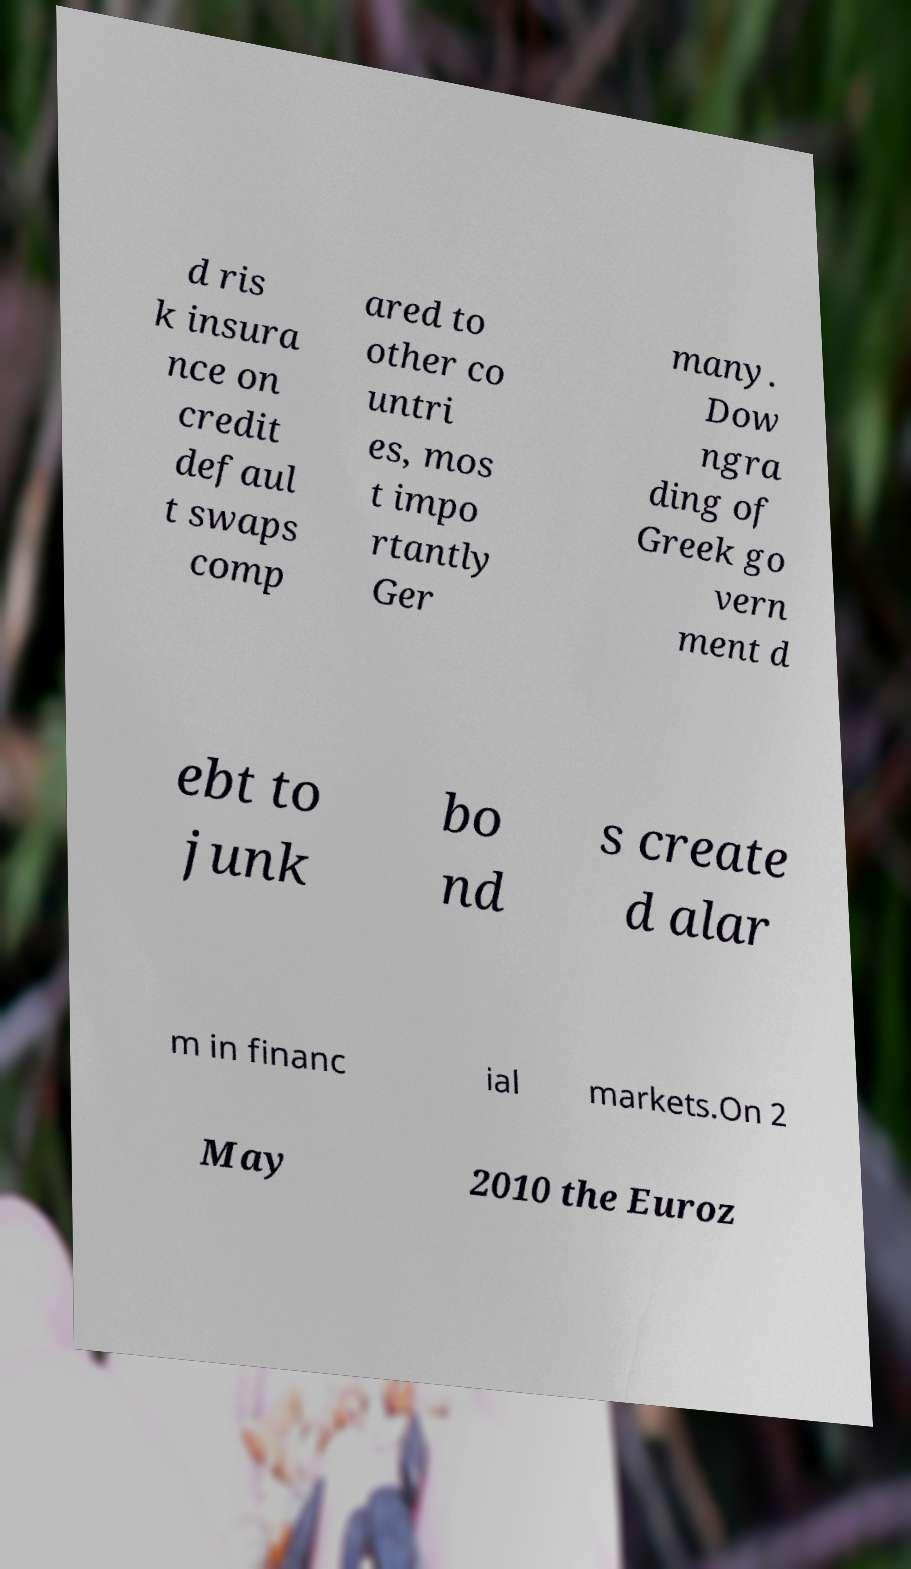What messages or text are displayed in this image? I need them in a readable, typed format. d ris k insura nce on credit defaul t swaps comp ared to other co untri es, mos t impo rtantly Ger many. Dow ngra ding of Greek go vern ment d ebt to junk bo nd s create d alar m in financ ial markets.On 2 May 2010 the Euroz 